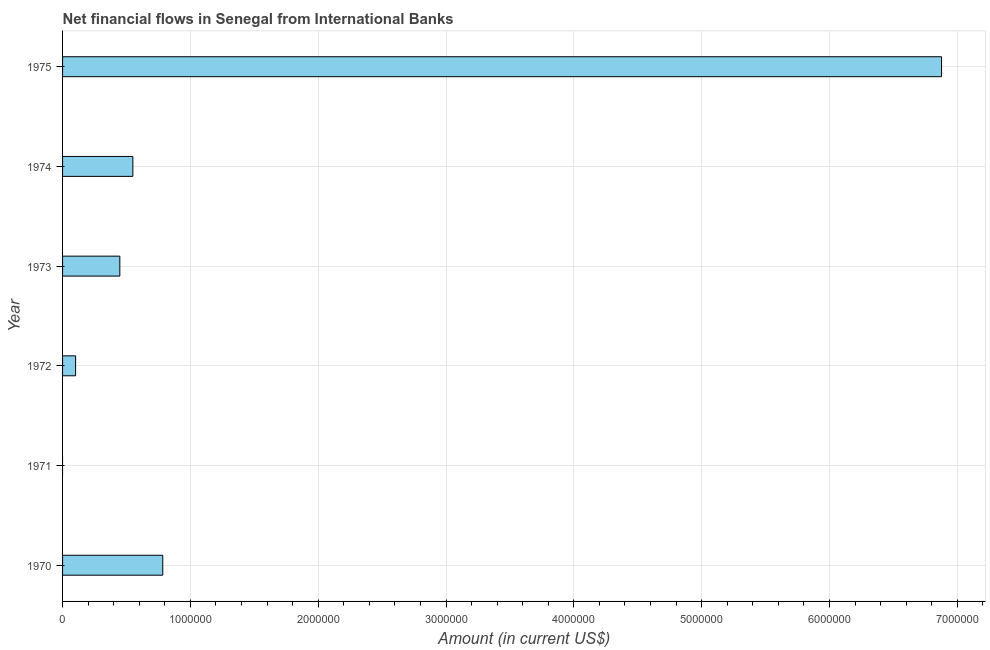Does the graph contain any zero values?
Offer a very short reply. Yes. What is the title of the graph?
Keep it short and to the point. Net financial flows in Senegal from International Banks. What is the label or title of the Y-axis?
Keep it short and to the point. Year. What is the net financial flows from ibrd in 1975?
Give a very brief answer. 6.88e+06. Across all years, what is the maximum net financial flows from ibrd?
Provide a short and direct response. 6.88e+06. Across all years, what is the minimum net financial flows from ibrd?
Ensure brevity in your answer.  0. In which year was the net financial flows from ibrd maximum?
Your response must be concise. 1975. What is the sum of the net financial flows from ibrd?
Keep it short and to the point. 8.76e+06. What is the difference between the net financial flows from ibrd in 1970 and 1972?
Your answer should be compact. 6.82e+05. What is the average net financial flows from ibrd per year?
Offer a very short reply. 1.46e+06. What is the median net financial flows from ibrd?
Your answer should be compact. 4.99e+05. What is the ratio of the net financial flows from ibrd in 1970 to that in 1974?
Your answer should be compact. 1.43. Is the net financial flows from ibrd in 1970 less than that in 1975?
Give a very brief answer. Yes. What is the difference between the highest and the second highest net financial flows from ibrd?
Make the answer very short. 6.09e+06. What is the difference between the highest and the lowest net financial flows from ibrd?
Your answer should be compact. 6.88e+06. In how many years, is the net financial flows from ibrd greater than the average net financial flows from ibrd taken over all years?
Offer a terse response. 1. How many bars are there?
Make the answer very short. 5. Are all the bars in the graph horizontal?
Your answer should be compact. Yes. What is the difference between two consecutive major ticks on the X-axis?
Your answer should be very brief. 1.00e+06. What is the Amount (in current US$) in 1970?
Your answer should be compact. 7.84e+05. What is the Amount (in current US$) of 1972?
Give a very brief answer. 1.02e+05. What is the Amount (in current US$) of 1973?
Your answer should be compact. 4.48e+05. What is the Amount (in current US$) of 1975?
Your answer should be compact. 6.88e+06. What is the difference between the Amount (in current US$) in 1970 and 1972?
Your answer should be very brief. 6.82e+05. What is the difference between the Amount (in current US$) in 1970 and 1973?
Your answer should be compact. 3.36e+05. What is the difference between the Amount (in current US$) in 1970 and 1974?
Provide a succinct answer. 2.34e+05. What is the difference between the Amount (in current US$) in 1970 and 1975?
Your response must be concise. -6.09e+06. What is the difference between the Amount (in current US$) in 1972 and 1973?
Give a very brief answer. -3.46e+05. What is the difference between the Amount (in current US$) in 1972 and 1974?
Keep it short and to the point. -4.48e+05. What is the difference between the Amount (in current US$) in 1972 and 1975?
Your answer should be very brief. -6.78e+06. What is the difference between the Amount (in current US$) in 1973 and 1974?
Your response must be concise. -1.02e+05. What is the difference between the Amount (in current US$) in 1973 and 1975?
Provide a succinct answer. -6.43e+06. What is the difference between the Amount (in current US$) in 1974 and 1975?
Ensure brevity in your answer.  -6.33e+06. What is the ratio of the Amount (in current US$) in 1970 to that in 1972?
Give a very brief answer. 7.69. What is the ratio of the Amount (in current US$) in 1970 to that in 1973?
Your answer should be very brief. 1.75. What is the ratio of the Amount (in current US$) in 1970 to that in 1974?
Give a very brief answer. 1.43. What is the ratio of the Amount (in current US$) in 1970 to that in 1975?
Keep it short and to the point. 0.11. What is the ratio of the Amount (in current US$) in 1972 to that in 1973?
Your response must be concise. 0.23. What is the ratio of the Amount (in current US$) in 1972 to that in 1974?
Your answer should be compact. 0.18. What is the ratio of the Amount (in current US$) in 1972 to that in 1975?
Make the answer very short. 0.01. What is the ratio of the Amount (in current US$) in 1973 to that in 1974?
Your answer should be compact. 0.81. What is the ratio of the Amount (in current US$) in 1973 to that in 1975?
Ensure brevity in your answer.  0.07. 